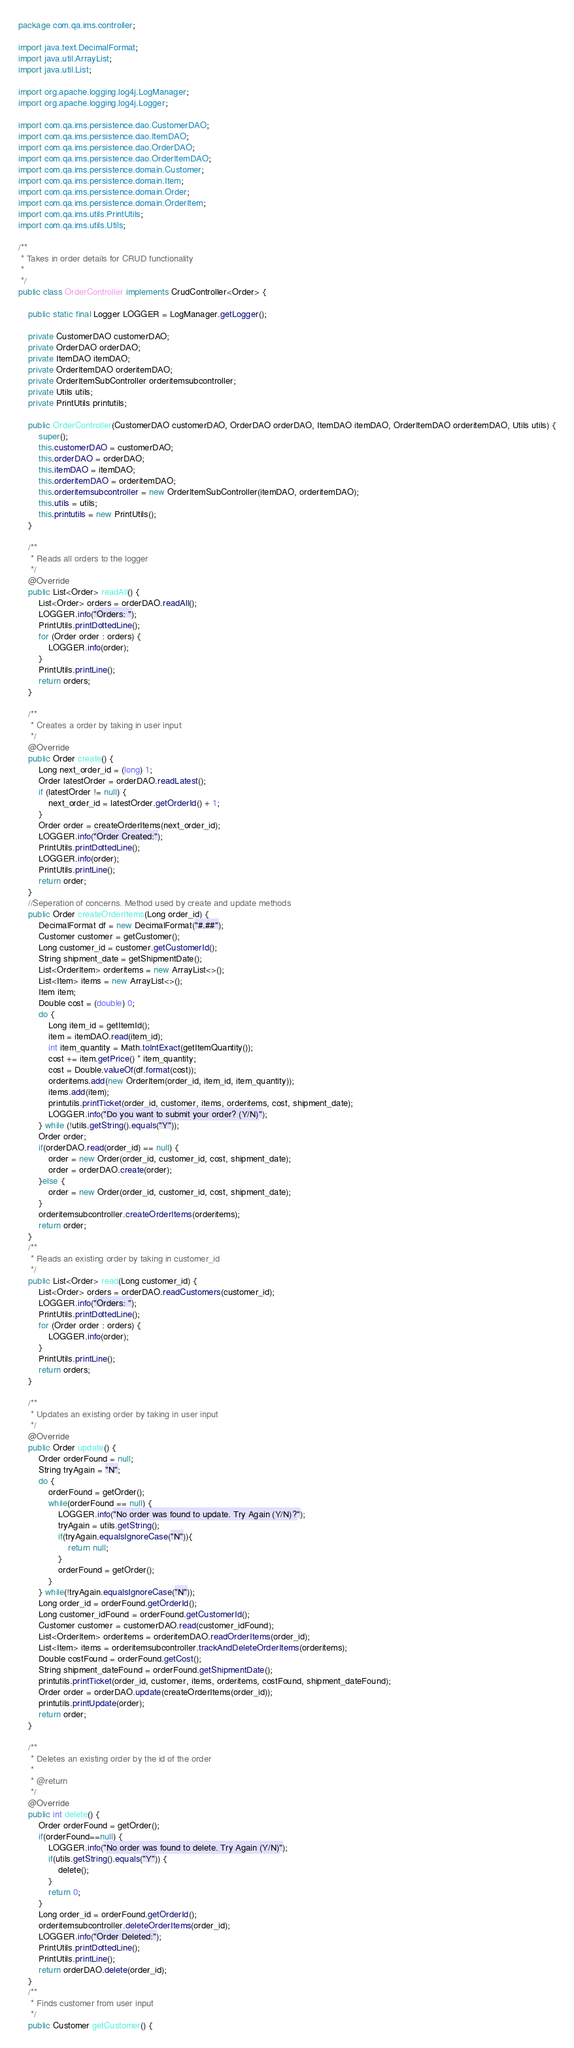Convert code to text. <code><loc_0><loc_0><loc_500><loc_500><_Java_>package com.qa.ims.controller;

import java.text.DecimalFormat;
import java.util.ArrayList;
import java.util.List;

import org.apache.logging.log4j.LogManager;
import org.apache.logging.log4j.Logger;

import com.qa.ims.persistence.dao.CustomerDAO;
import com.qa.ims.persistence.dao.ItemDAO;
import com.qa.ims.persistence.dao.OrderDAO;
import com.qa.ims.persistence.dao.OrderItemDAO;
import com.qa.ims.persistence.domain.Customer;
import com.qa.ims.persistence.domain.Item;
import com.qa.ims.persistence.domain.Order;
import com.qa.ims.persistence.domain.OrderItem;
import com.qa.ims.utils.PrintUtils;
import com.qa.ims.utils.Utils;

/**
 * Takes in order details for CRUD functionality
 *
 */
public class OrderController implements CrudController<Order> {

	public static final Logger LOGGER = LogManager.getLogger();
	
	private CustomerDAO customerDAO;
	private OrderDAO orderDAO;
	private ItemDAO itemDAO;
	private OrderItemDAO orderitemDAO;
	private OrderItemSubController orderitemsubcontroller;
	private Utils utils;
	private PrintUtils printutils;

	public OrderController(CustomerDAO customerDAO, OrderDAO orderDAO, ItemDAO itemDAO, OrderItemDAO orderitemDAO, Utils utils) {
		super();
		this.customerDAO = customerDAO;
		this.orderDAO = orderDAO;
		this.itemDAO = itemDAO;
		this.orderitemDAO = orderitemDAO;
		this.orderitemsubcontroller = new OrderItemSubController(itemDAO, orderitemDAO);
		this.utils = utils;
		this.printutils = new PrintUtils();
	}

	/**
	 * Reads all orders to the logger
	 */
	@Override
	public List<Order> readAll() {
		List<Order> orders = orderDAO.readAll();
		LOGGER.info("Orders: ");
		PrintUtils.printDottedLine();
		for (Order order : orders) {
			LOGGER.info(order);
		}
		PrintUtils.printLine();
		return orders;
	}

	/**
	 * Creates a order by taking in user input
	 */
	@Override
	public Order create() {
		Long next_order_id = (long) 1;
		Order latestOrder = orderDAO.readLatest();
		if (latestOrder != null) {
			next_order_id = latestOrder.getOrderId() + 1;
		}
		Order order = createOrderItems(next_order_id);
		LOGGER.info("Order Created:");
		PrintUtils.printDottedLine();
		LOGGER.info(order);
		PrintUtils.printLine();
		return order;
	}
	//Seperation of concerns. Method used by create and update methods
	public Order createOrderItems(Long order_id) {
		DecimalFormat df = new DecimalFormat("#.##");
		Customer customer = getCustomer();
		Long customer_id = customer.getCustomerId();
		String shipment_date = getShipmentDate();
		List<OrderItem> orderitems = new ArrayList<>();
		List<Item> items = new ArrayList<>();
		Item item;
		Double cost = (double) 0;
		do {
			Long item_id = getItemId();
			item = itemDAO.read(item_id);
			int item_quantity = Math.toIntExact(getItemQuantity());
			cost += item.getPrice() * item_quantity;
			cost = Double.valueOf(df.format(cost));
			orderitems.add(new OrderItem(order_id, item_id, item_quantity));
			items.add(item);
			printutils.printTicket(order_id, customer, items, orderitems, cost, shipment_date);
			LOGGER.info("Do you want to submit your order? (Y/N)");
		} while (!utils.getString().equals("Y"));
		Order order;
		if(orderDAO.read(order_id) == null) {
			order = new Order(order_id, customer_id, cost, shipment_date);
			order = orderDAO.create(order);
		}else {
			order = new Order(order_id, customer_id, cost, shipment_date);
		}
		orderitemsubcontroller.createOrderItems(orderitems);
		return order;
	}
	/**
	 * Reads an existing order by taking in customer_id
	 */
	public List<Order> read(Long customer_id) {
		List<Order> orders = orderDAO.readCustomers(customer_id);
		LOGGER.info("Orders: ");
		PrintUtils.printDottedLine();
		for (Order order : orders) {
			LOGGER.info(order);
		}
		PrintUtils.printLine();
		return orders;
	}
	
	/**
	 * Updates an existing order by taking in user input
	 */
	@Override
	public Order update() {
		Order orderFound = null;
		String tryAgain = "N";
		do {
			orderFound = getOrder();
			while(orderFound == null) {
				LOGGER.info("No order was found to update. Try Again (Y/N)?");
				tryAgain = utils.getString();
				if(tryAgain.equalsIgnoreCase("N")){
					return null;
				}
				orderFound = getOrder();		
			}
		} while(!tryAgain.equalsIgnoreCase("N"));
		Long order_id = orderFound.getOrderId();	
		Long customer_idFound = orderFound.getCustomerId();
		Customer customer = customerDAO.read(customer_idFound);
		List<OrderItem> orderitems = orderitemDAO.readOrderItems(order_id);
		List<Item> items = orderitemsubcontroller.trackAndDeleteOrderItems(orderitems);
		Double costFound = orderFound.getCost();
		String shipment_dateFound = orderFound.getShipmentDate();
		printutils.printTicket(order_id, customer, items, orderitems, costFound, shipment_dateFound);
		Order order = orderDAO.update(createOrderItems(order_id));
		printutils.printUpdate(order);
		return order;
	}

	/**
	 * Deletes an existing order by the id of the order
	 * 
	 * @return
	 */
	@Override
	public int delete() {
		Order orderFound = getOrder();
		if(orderFound==null) {
			LOGGER.info("No order was found to delete. Try Again (Y/N)");
			if(utils.getString().equals("Y")) {
				delete();
			}
			return 0;
		}
		Long order_id = orderFound.getOrderId();
		orderitemsubcontroller.deleteOrderItems(order_id);
		LOGGER.info("Order Deleted:");
		PrintUtils.printDottedLine();
		PrintUtils.printLine();
		return orderDAO.delete(order_id);
	}
	/**
	 * Finds customer from user input
	 */
	public Customer getCustomer() {</code> 